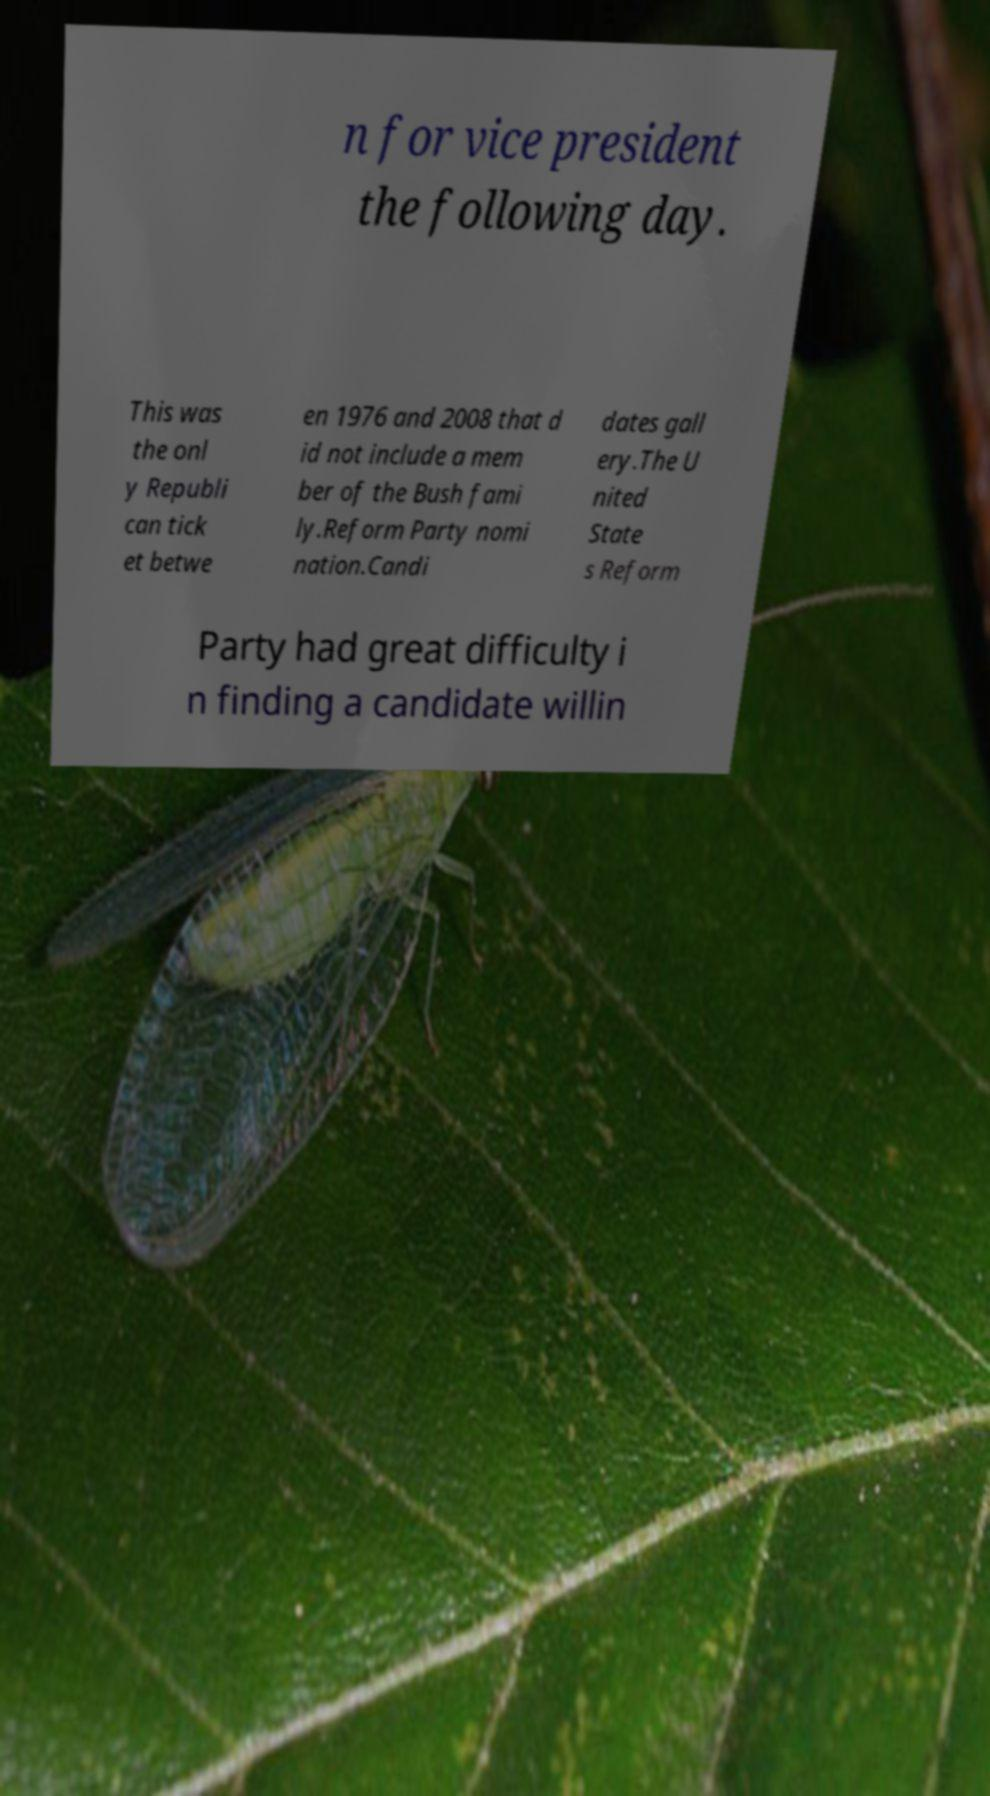What messages or text are displayed in this image? I need them in a readable, typed format. n for vice president the following day. This was the onl y Republi can tick et betwe en 1976 and 2008 that d id not include a mem ber of the Bush fami ly.Reform Party nomi nation.Candi dates gall ery.The U nited State s Reform Party had great difficulty i n finding a candidate willin 